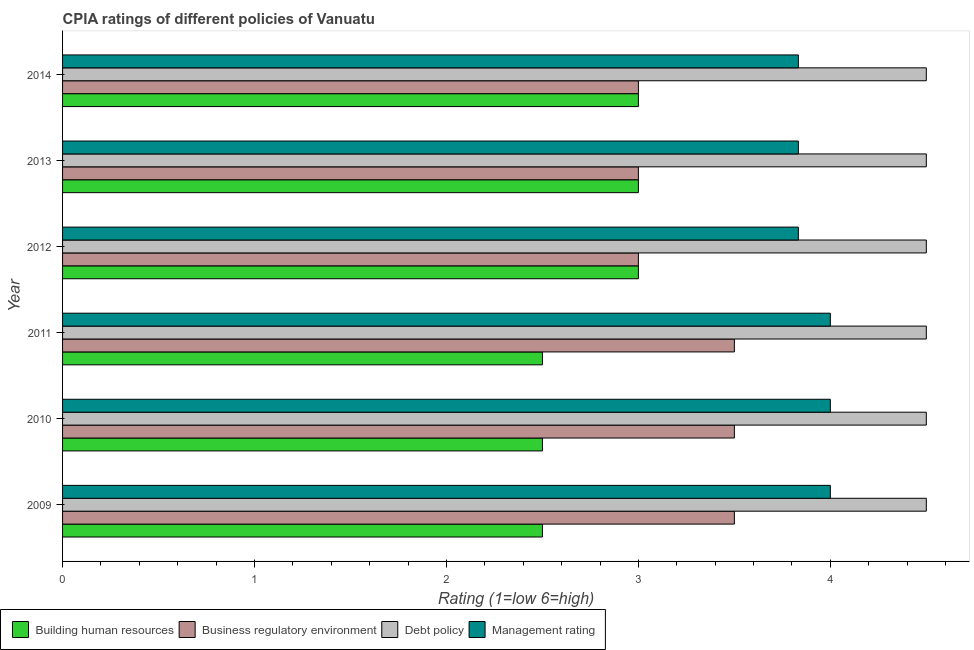Are the number of bars per tick equal to the number of legend labels?
Provide a succinct answer. Yes. Are the number of bars on each tick of the Y-axis equal?
Ensure brevity in your answer.  Yes. How many bars are there on the 6th tick from the top?
Your response must be concise. 4. What is the label of the 4th group of bars from the top?
Your response must be concise. 2011. Across all years, what is the minimum cpia rating of business regulatory environment?
Your response must be concise. 3. In which year was the cpia rating of debt policy minimum?
Give a very brief answer. 2009. What is the difference between the cpia rating of debt policy in 2009 and the cpia rating of building human resources in 2011?
Provide a short and direct response. 2. What is the average cpia rating of management per year?
Make the answer very short. 3.92. In the year 2014, what is the difference between the cpia rating of management and cpia rating of debt policy?
Offer a very short reply. -0.67. What is the ratio of the cpia rating of business regulatory environment in 2012 to that in 2013?
Your answer should be very brief. 1. Is the cpia rating of debt policy in 2013 less than that in 2014?
Your response must be concise. No. Is the difference between the cpia rating of debt policy in 2012 and 2014 greater than the difference between the cpia rating of management in 2012 and 2014?
Offer a terse response. No. What is the difference between the highest and the lowest cpia rating of debt policy?
Your response must be concise. 0. Is it the case that in every year, the sum of the cpia rating of building human resources and cpia rating of debt policy is greater than the sum of cpia rating of management and cpia rating of business regulatory environment?
Offer a very short reply. No. What does the 1st bar from the top in 2014 represents?
Provide a succinct answer. Management rating. What does the 3rd bar from the bottom in 2012 represents?
Offer a very short reply. Debt policy. Is it the case that in every year, the sum of the cpia rating of building human resources and cpia rating of business regulatory environment is greater than the cpia rating of debt policy?
Your answer should be very brief. Yes. Does the graph contain any zero values?
Keep it short and to the point. No. Does the graph contain grids?
Ensure brevity in your answer.  No. How many legend labels are there?
Offer a terse response. 4. What is the title of the graph?
Your answer should be compact. CPIA ratings of different policies of Vanuatu. What is the label or title of the X-axis?
Your answer should be very brief. Rating (1=low 6=high). What is the label or title of the Y-axis?
Your answer should be very brief. Year. What is the Rating (1=low 6=high) in Building human resources in 2009?
Provide a short and direct response. 2.5. What is the Rating (1=low 6=high) of Business regulatory environment in 2009?
Give a very brief answer. 3.5. What is the Rating (1=low 6=high) of Management rating in 2009?
Offer a very short reply. 4. What is the Rating (1=low 6=high) of Business regulatory environment in 2010?
Ensure brevity in your answer.  3.5. What is the Rating (1=low 6=high) of Management rating in 2010?
Provide a succinct answer. 4. What is the Rating (1=low 6=high) of Building human resources in 2011?
Provide a short and direct response. 2.5. What is the Rating (1=low 6=high) in Debt policy in 2011?
Offer a terse response. 4.5. What is the Rating (1=low 6=high) in Business regulatory environment in 2012?
Your response must be concise. 3. What is the Rating (1=low 6=high) in Debt policy in 2012?
Your response must be concise. 4.5. What is the Rating (1=low 6=high) in Management rating in 2012?
Offer a terse response. 3.83. What is the Rating (1=low 6=high) in Building human resources in 2013?
Offer a very short reply. 3. What is the Rating (1=low 6=high) of Business regulatory environment in 2013?
Provide a succinct answer. 3. What is the Rating (1=low 6=high) in Debt policy in 2013?
Your answer should be very brief. 4.5. What is the Rating (1=low 6=high) of Management rating in 2013?
Offer a terse response. 3.83. What is the Rating (1=low 6=high) of Building human resources in 2014?
Provide a succinct answer. 3. What is the Rating (1=low 6=high) in Business regulatory environment in 2014?
Ensure brevity in your answer.  3. What is the Rating (1=low 6=high) of Management rating in 2014?
Provide a short and direct response. 3.83. Across all years, what is the maximum Rating (1=low 6=high) in Building human resources?
Your answer should be compact. 3. Across all years, what is the minimum Rating (1=low 6=high) in Building human resources?
Give a very brief answer. 2.5. Across all years, what is the minimum Rating (1=low 6=high) in Management rating?
Provide a succinct answer. 3.83. What is the total Rating (1=low 6=high) in Business regulatory environment in the graph?
Your answer should be compact. 19.5. What is the total Rating (1=low 6=high) of Management rating in the graph?
Provide a succinct answer. 23.5. What is the difference between the Rating (1=low 6=high) in Business regulatory environment in 2009 and that in 2010?
Give a very brief answer. 0. What is the difference between the Rating (1=low 6=high) in Debt policy in 2009 and that in 2010?
Provide a short and direct response. 0. What is the difference between the Rating (1=low 6=high) in Management rating in 2009 and that in 2010?
Make the answer very short. 0. What is the difference between the Rating (1=low 6=high) in Debt policy in 2009 and that in 2011?
Ensure brevity in your answer.  0. What is the difference between the Rating (1=low 6=high) of Building human resources in 2009 and that in 2012?
Your answer should be compact. -0.5. What is the difference between the Rating (1=low 6=high) of Business regulatory environment in 2009 and that in 2012?
Give a very brief answer. 0.5. What is the difference between the Rating (1=low 6=high) in Management rating in 2009 and that in 2012?
Ensure brevity in your answer.  0.17. What is the difference between the Rating (1=low 6=high) in Business regulatory environment in 2009 and that in 2013?
Offer a very short reply. 0.5. What is the difference between the Rating (1=low 6=high) of Debt policy in 2009 and that in 2013?
Offer a very short reply. 0. What is the difference between the Rating (1=low 6=high) in Debt policy in 2009 and that in 2014?
Make the answer very short. 0. What is the difference between the Rating (1=low 6=high) in Building human resources in 2010 and that in 2011?
Your answer should be very brief. 0. What is the difference between the Rating (1=low 6=high) of Debt policy in 2010 and that in 2011?
Give a very brief answer. 0. What is the difference between the Rating (1=low 6=high) of Management rating in 2010 and that in 2011?
Make the answer very short. 0. What is the difference between the Rating (1=low 6=high) of Business regulatory environment in 2010 and that in 2012?
Your answer should be compact. 0.5. What is the difference between the Rating (1=low 6=high) of Management rating in 2010 and that in 2012?
Provide a succinct answer. 0.17. What is the difference between the Rating (1=low 6=high) in Building human resources in 2010 and that in 2013?
Your response must be concise. -0.5. What is the difference between the Rating (1=low 6=high) of Management rating in 2010 and that in 2013?
Make the answer very short. 0.17. What is the difference between the Rating (1=low 6=high) in Building human resources in 2010 and that in 2014?
Make the answer very short. -0.5. What is the difference between the Rating (1=low 6=high) of Management rating in 2010 and that in 2014?
Give a very brief answer. 0.17. What is the difference between the Rating (1=low 6=high) in Building human resources in 2011 and that in 2012?
Offer a terse response. -0.5. What is the difference between the Rating (1=low 6=high) of Debt policy in 2011 and that in 2012?
Your answer should be very brief. 0. What is the difference between the Rating (1=low 6=high) of Management rating in 2011 and that in 2012?
Ensure brevity in your answer.  0.17. What is the difference between the Rating (1=low 6=high) in Business regulatory environment in 2011 and that in 2013?
Your answer should be compact. 0.5. What is the difference between the Rating (1=low 6=high) of Management rating in 2011 and that in 2014?
Your answer should be compact. 0.17. What is the difference between the Rating (1=low 6=high) of Building human resources in 2012 and that in 2013?
Ensure brevity in your answer.  0. What is the difference between the Rating (1=low 6=high) in Business regulatory environment in 2012 and that in 2013?
Keep it short and to the point. 0. What is the difference between the Rating (1=low 6=high) in Business regulatory environment in 2012 and that in 2014?
Your answer should be compact. 0. What is the difference between the Rating (1=low 6=high) in Debt policy in 2012 and that in 2014?
Keep it short and to the point. 0. What is the difference between the Rating (1=low 6=high) in Building human resources in 2013 and that in 2014?
Give a very brief answer. 0. What is the difference between the Rating (1=low 6=high) in Business regulatory environment in 2013 and that in 2014?
Your answer should be very brief. 0. What is the difference between the Rating (1=low 6=high) in Management rating in 2013 and that in 2014?
Provide a succinct answer. 0. What is the difference between the Rating (1=low 6=high) of Business regulatory environment in 2009 and the Rating (1=low 6=high) of Debt policy in 2010?
Offer a very short reply. -1. What is the difference between the Rating (1=low 6=high) in Business regulatory environment in 2009 and the Rating (1=low 6=high) in Management rating in 2010?
Provide a succinct answer. -0.5. What is the difference between the Rating (1=low 6=high) of Debt policy in 2009 and the Rating (1=low 6=high) of Management rating in 2010?
Provide a succinct answer. 0.5. What is the difference between the Rating (1=low 6=high) of Building human resources in 2009 and the Rating (1=low 6=high) of Business regulatory environment in 2011?
Your answer should be compact. -1. What is the difference between the Rating (1=low 6=high) of Business regulatory environment in 2009 and the Rating (1=low 6=high) of Debt policy in 2011?
Your response must be concise. -1. What is the difference between the Rating (1=low 6=high) in Business regulatory environment in 2009 and the Rating (1=low 6=high) in Management rating in 2011?
Give a very brief answer. -0.5. What is the difference between the Rating (1=low 6=high) in Debt policy in 2009 and the Rating (1=low 6=high) in Management rating in 2011?
Make the answer very short. 0.5. What is the difference between the Rating (1=low 6=high) in Building human resources in 2009 and the Rating (1=low 6=high) in Business regulatory environment in 2012?
Offer a terse response. -0.5. What is the difference between the Rating (1=low 6=high) of Building human resources in 2009 and the Rating (1=low 6=high) of Debt policy in 2012?
Offer a terse response. -2. What is the difference between the Rating (1=low 6=high) in Building human resources in 2009 and the Rating (1=low 6=high) in Management rating in 2012?
Make the answer very short. -1.33. What is the difference between the Rating (1=low 6=high) of Business regulatory environment in 2009 and the Rating (1=low 6=high) of Management rating in 2012?
Your answer should be compact. -0.33. What is the difference between the Rating (1=low 6=high) of Debt policy in 2009 and the Rating (1=low 6=high) of Management rating in 2012?
Keep it short and to the point. 0.67. What is the difference between the Rating (1=low 6=high) in Building human resources in 2009 and the Rating (1=low 6=high) in Debt policy in 2013?
Your response must be concise. -2. What is the difference between the Rating (1=low 6=high) in Building human resources in 2009 and the Rating (1=low 6=high) in Management rating in 2013?
Offer a very short reply. -1.33. What is the difference between the Rating (1=low 6=high) of Business regulatory environment in 2009 and the Rating (1=low 6=high) of Debt policy in 2013?
Ensure brevity in your answer.  -1. What is the difference between the Rating (1=low 6=high) in Business regulatory environment in 2009 and the Rating (1=low 6=high) in Management rating in 2013?
Ensure brevity in your answer.  -0.33. What is the difference between the Rating (1=low 6=high) in Debt policy in 2009 and the Rating (1=low 6=high) in Management rating in 2013?
Offer a terse response. 0.67. What is the difference between the Rating (1=low 6=high) of Building human resources in 2009 and the Rating (1=low 6=high) of Debt policy in 2014?
Offer a terse response. -2. What is the difference between the Rating (1=low 6=high) in Building human resources in 2009 and the Rating (1=low 6=high) in Management rating in 2014?
Offer a very short reply. -1.33. What is the difference between the Rating (1=low 6=high) in Business regulatory environment in 2009 and the Rating (1=low 6=high) in Debt policy in 2014?
Make the answer very short. -1. What is the difference between the Rating (1=low 6=high) of Debt policy in 2009 and the Rating (1=low 6=high) of Management rating in 2014?
Your response must be concise. 0.67. What is the difference between the Rating (1=low 6=high) of Building human resources in 2010 and the Rating (1=low 6=high) of Business regulatory environment in 2011?
Give a very brief answer. -1. What is the difference between the Rating (1=low 6=high) of Building human resources in 2010 and the Rating (1=low 6=high) of Management rating in 2012?
Make the answer very short. -1.33. What is the difference between the Rating (1=low 6=high) of Business regulatory environment in 2010 and the Rating (1=low 6=high) of Management rating in 2012?
Provide a succinct answer. -0.33. What is the difference between the Rating (1=low 6=high) of Building human resources in 2010 and the Rating (1=low 6=high) of Debt policy in 2013?
Make the answer very short. -2. What is the difference between the Rating (1=low 6=high) of Building human resources in 2010 and the Rating (1=low 6=high) of Management rating in 2013?
Keep it short and to the point. -1.33. What is the difference between the Rating (1=low 6=high) of Business regulatory environment in 2010 and the Rating (1=low 6=high) of Management rating in 2013?
Provide a succinct answer. -0.33. What is the difference between the Rating (1=low 6=high) in Debt policy in 2010 and the Rating (1=low 6=high) in Management rating in 2013?
Offer a very short reply. 0.67. What is the difference between the Rating (1=low 6=high) in Building human resources in 2010 and the Rating (1=low 6=high) in Debt policy in 2014?
Keep it short and to the point. -2. What is the difference between the Rating (1=low 6=high) of Building human resources in 2010 and the Rating (1=low 6=high) of Management rating in 2014?
Make the answer very short. -1.33. What is the difference between the Rating (1=low 6=high) in Building human resources in 2011 and the Rating (1=low 6=high) in Business regulatory environment in 2012?
Keep it short and to the point. -0.5. What is the difference between the Rating (1=low 6=high) in Building human resources in 2011 and the Rating (1=low 6=high) in Management rating in 2012?
Provide a succinct answer. -1.33. What is the difference between the Rating (1=low 6=high) in Debt policy in 2011 and the Rating (1=low 6=high) in Management rating in 2012?
Offer a terse response. 0.67. What is the difference between the Rating (1=low 6=high) of Building human resources in 2011 and the Rating (1=low 6=high) of Business regulatory environment in 2013?
Your answer should be compact. -0.5. What is the difference between the Rating (1=low 6=high) of Building human resources in 2011 and the Rating (1=low 6=high) of Management rating in 2013?
Ensure brevity in your answer.  -1.33. What is the difference between the Rating (1=low 6=high) of Business regulatory environment in 2011 and the Rating (1=low 6=high) of Debt policy in 2013?
Give a very brief answer. -1. What is the difference between the Rating (1=low 6=high) in Business regulatory environment in 2011 and the Rating (1=low 6=high) in Management rating in 2013?
Keep it short and to the point. -0.33. What is the difference between the Rating (1=low 6=high) in Debt policy in 2011 and the Rating (1=low 6=high) in Management rating in 2013?
Your response must be concise. 0.67. What is the difference between the Rating (1=low 6=high) in Building human resources in 2011 and the Rating (1=low 6=high) in Business regulatory environment in 2014?
Your answer should be compact. -0.5. What is the difference between the Rating (1=low 6=high) in Building human resources in 2011 and the Rating (1=low 6=high) in Management rating in 2014?
Make the answer very short. -1.33. What is the difference between the Rating (1=low 6=high) in Business regulatory environment in 2011 and the Rating (1=low 6=high) in Debt policy in 2014?
Keep it short and to the point. -1. What is the difference between the Rating (1=low 6=high) in Business regulatory environment in 2011 and the Rating (1=low 6=high) in Management rating in 2014?
Provide a short and direct response. -0.33. What is the difference between the Rating (1=low 6=high) in Debt policy in 2011 and the Rating (1=low 6=high) in Management rating in 2014?
Your answer should be very brief. 0.67. What is the difference between the Rating (1=low 6=high) in Building human resources in 2012 and the Rating (1=low 6=high) in Business regulatory environment in 2013?
Provide a short and direct response. 0. What is the difference between the Rating (1=low 6=high) of Building human resources in 2012 and the Rating (1=low 6=high) of Management rating in 2013?
Make the answer very short. -0.83. What is the difference between the Rating (1=low 6=high) in Business regulatory environment in 2013 and the Rating (1=low 6=high) in Debt policy in 2014?
Provide a succinct answer. -1.5. What is the difference between the Rating (1=low 6=high) of Business regulatory environment in 2013 and the Rating (1=low 6=high) of Management rating in 2014?
Your answer should be compact. -0.83. What is the average Rating (1=low 6=high) of Building human resources per year?
Offer a very short reply. 2.75. What is the average Rating (1=low 6=high) in Business regulatory environment per year?
Offer a terse response. 3.25. What is the average Rating (1=low 6=high) of Debt policy per year?
Your answer should be compact. 4.5. What is the average Rating (1=low 6=high) of Management rating per year?
Give a very brief answer. 3.92. In the year 2009, what is the difference between the Rating (1=low 6=high) in Building human resources and Rating (1=low 6=high) in Debt policy?
Provide a short and direct response. -2. In the year 2009, what is the difference between the Rating (1=low 6=high) in Business regulatory environment and Rating (1=low 6=high) in Debt policy?
Offer a very short reply. -1. In the year 2009, what is the difference between the Rating (1=low 6=high) of Business regulatory environment and Rating (1=low 6=high) of Management rating?
Your answer should be compact. -0.5. In the year 2009, what is the difference between the Rating (1=low 6=high) in Debt policy and Rating (1=low 6=high) in Management rating?
Ensure brevity in your answer.  0.5. In the year 2010, what is the difference between the Rating (1=low 6=high) in Building human resources and Rating (1=low 6=high) in Management rating?
Offer a terse response. -1.5. In the year 2010, what is the difference between the Rating (1=low 6=high) in Business regulatory environment and Rating (1=low 6=high) in Debt policy?
Ensure brevity in your answer.  -1. In the year 2010, what is the difference between the Rating (1=low 6=high) in Business regulatory environment and Rating (1=low 6=high) in Management rating?
Keep it short and to the point. -0.5. In the year 2010, what is the difference between the Rating (1=low 6=high) in Debt policy and Rating (1=low 6=high) in Management rating?
Keep it short and to the point. 0.5. In the year 2011, what is the difference between the Rating (1=low 6=high) of Building human resources and Rating (1=low 6=high) of Management rating?
Your answer should be compact. -1.5. In the year 2012, what is the difference between the Rating (1=low 6=high) in Building human resources and Rating (1=low 6=high) in Business regulatory environment?
Give a very brief answer. 0. In the year 2012, what is the difference between the Rating (1=low 6=high) of Building human resources and Rating (1=low 6=high) of Debt policy?
Provide a short and direct response. -1.5. In the year 2012, what is the difference between the Rating (1=low 6=high) in Building human resources and Rating (1=low 6=high) in Management rating?
Make the answer very short. -0.83. In the year 2012, what is the difference between the Rating (1=low 6=high) of Debt policy and Rating (1=low 6=high) of Management rating?
Your answer should be compact. 0.67. In the year 2013, what is the difference between the Rating (1=low 6=high) of Building human resources and Rating (1=low 6=high) of Management rating?
Provide a succinct answer. -0.83. In the year 2013, what is the difference between the Rating (1=low 6=high) of Business regulatory environment and Rating (1=low 6=high) of Debt policy?
Give a very brief answer. -1.5. In the year 2013, what is the difference between the Rating (1=low 6=high) in Business regulatory environment and Rating (1=low 6=high) in Management rating?
Ensure brevity in your answer.  -0.83. In the year 2014, what is the difference between the Rating (1=low 6=high) of Business regulatory environment and Rating (1=low 6=high) of Debt policy?
Provide a short and direct response. -1.5. In the year 2014, what is the difference between the Rating (1=low 6=high) in Debt policy and Rating (1=low 6=high) in Management rating?
Your answer should be compact. 0.67. What is the ratio of the Rating (1=low 6=high) of Business regulatory environment in 2009 to that in 2010?
Your response must be concise. 1. What is the ratio of the Rating (1=low 6=high) of Debt policy in 2009 to that in 2010?
Your answer should be very brief. 1. What is the ratio of the Rating (1=low 6=high) in Management rating in 2009 to that in 2010?
Your answer should be compact. 1. What is the ratio of the Rating (1=low 6=high) in Debt policy in 2009 to that in 2011?
Keep it short and to the point. 1. What is the ratio of the Rating (1=low 6=high) of Management rating in 2009 to that in 2011?
Ensure brevity in your answer.  1. What is the ratio of the Rating (1=low 6=high) of Business regulatory environment in 2009 to that in 2012?
Your response must be concise. 1.17. What is the ratio of the Rating (1=low 6=high) in Debt policy in 2009 to that in 2012?
Make the answer very short. 1. What is the ratio of the Rating (1=low 6=high) in Management rating in 2009 to that in 2012?
Provide a succinct answer. 1.04. What is the ratio of the Rating (1=low 6=high) of Business regulatory environment in 2009 to that in 2013?
Your answer should be compact. 1.17. What is the ratio of the Rating (1=low 6=high) in Management rating in 2009 to that in 2013?
Your answer should be very brief. 1.04. What is the ratio of the Rating (1=low 6=high) of Building human resources in 2009 to that in 2014?
Provide a succinct answer. 0.83. What is the ratio of the Rating (1=low 6=high) of Management rating in 2009 to that in 2014?
Provide a short and direct response. 1.04. What is the ratio of the Rating (1=low 6=high) in Building human resources in 2010 to that in 2011?
Ensure brevity in your answer.  1. What is the ratio of the Rating (1=low 6=high) of Building human resources in 2010 to that in 2012?
Your answer should be very brief. 0.83. What is the ratio of the Rating (1=low 6=high) in Business regulatory environment in 2010 to that in 2012?
Your answer should be very brief. 1.17. What is the ratio of the Rating (1=low 6=high) of Debt policy in 2010 to that in 2012?
Keep it short and to the point. 1. What is the ratio of the Rating (1=low 6=high) in Management rating in 2010 to that in 2012?
Offer a terse response. 1.04. What is the ratio of the Rating (1=low 6=high) in Building human resources in 2010 to that in 2013?
Your answer should be compact. 0.83. What is the ratio of the Rating (1=low 6=high) of Debt policy in 2010 to that in 2013?
Provide a short and direct response. 1. What is the ratio of the Rating (1=low 6=high) of Management rating in 2010 to that in 2013?
Offer a terse response. 1.04. What is the ratio of the Rating (1=low 6=high) of Business regulatory environment in 2010 to that in 2014?
Ensure brevity in your answer.  1.17. What is the ratio of the Rating (1=low 6=high) in Debt policy in 2010 to that in 2014?
Provide a succinct answer. 1. What is the ratio of the Rating (1=low 6=high) of Management rating in 2010 to that in 2014?
Provide a short and direct response. 1.04. What is the ratio of the Rating (1=low 6=high) of Building human resources in 2011 to that in 2012?
Provide a succinct answer. 0.83. What is the ratio of the Rating (1=low 6=high) of Business regulatory environment in 2011 to that in 2012?
Make the answer very short. 1.17. What is the ratio of the Rating (1=low 6=high) in Management rating in 2011 to that in 2012?
Provide a short and direct response. 1.04. What is the ratio of the Rating (1=low 6=high) in Management rating in 2011 to that in 2013?
Ensure brevity in your answer.  1.04. What is the ratio of the Rating (1=low 6=high) in Business regulatory environment in 2011 to that in 2014?
Offer a very short reply. 1.17. What is the ratio of the Rating (1=low 6=high) of Management rating in 2011 to that in 2014?
Your answer should be compact. 1.04. What is the ratio of the Rating (1=low 6=high) in Business regulatory environment in 2012 to that in 2013?
Your answer should be very brief. 1. What is the ratio of the Rating (1=low 6=high) in Management rating in 2012 to that in 2013?
Offer a terse response. 1. What is the ratio of the Rating (1=low 6=high) in Building human resources in 2012 to that in 2014?
Make the answer very short. 1. What is the ratio of the Rating (1=low 6=high) of Management rating in 2012 to that in 2014?
Your response must be concise. 1. What is the ratio of the Rating (1=low 6=high) in Building human resources in 2013 to that in 2014?
Provide a succinct answer. 1. What is the difference between the highest and the lowest Rating (1=low 6=high) in Building human resources?
Offer a very short reply. 0.5. What is the difference between the highest and the lowest Rating (1=low 6=high) of Business regulatory environment?
Offer a terse response. 0.5. What is the difference between the highest and the lowest Rating (1=low 6=high) in Debt policy?
Your response must be concise. 0. What is the difference between the highest and the lowest Rating (1=low 6=high) of Management rating?
Provide a succinct answer. 0.17. 